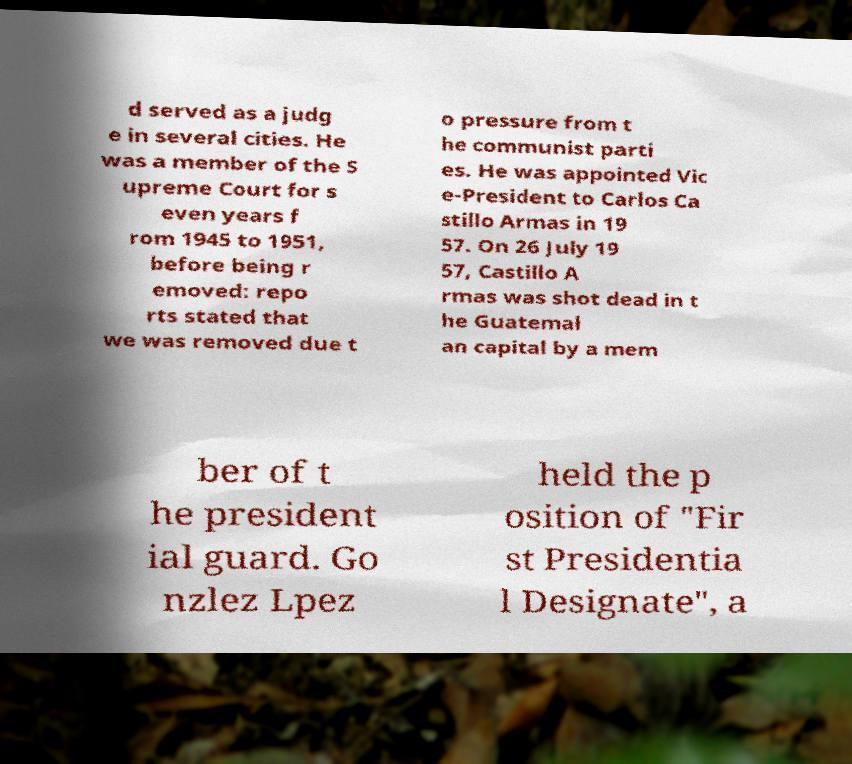There's text embedded in this image that I need extracted. Can you transcribe it verbatim? d served as a judg e in several cities. He was a member of the S upreme Court for s even years f rom 1945 to 1951, before being r emoved: repo rts stated that we was removed due t o pressure from t he communist parti es. He was appointed Vic e-President to Carlos Ca stillo Armas in 19 57. On 26 July 19 57, Castillo A rmas was shot dead in t he Guatemal an capital by a mem ber of t he president ial guard. Go nzlez Lpez held the p osition of "Fir st Presidentia l Designate", a 